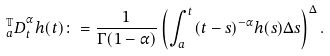Convert formula to latex. <formula><loc_0><loc_0><loc_500><loc_500>{ _ { a } ^ { \mathbb { T } } D } _ { t } ^ { \alpha } h ( t ) \colon = \frac { 1 } { \Gamma ( 1 - \alpha ) } \left ( \int _ { a } ^ { t } ( t - s ) ^ { - \alpha } h ( s ) \Delta s \right ) ^ { \Delta } .</formula> 